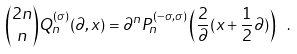Convert formula to latex. <formula><loc_0><loc_0><loc_500><loc_500>\binom { 2 n } { n } Q _ { n } ^ { ( \sigma ) } ( \partial , x ) = \partial ^ { n } P ^ { ( - \sigma , \sigma ) } _ { n } \left ( \frac { 2 } { \partial } ( x + \frac { 1 } { 2 } \partial ) \right ) \ .</formula> 